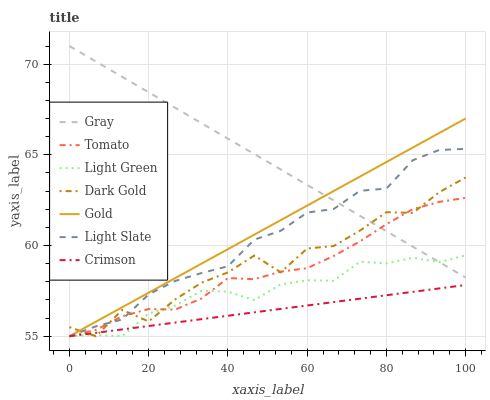Does Crimson have the minimum area under the curve?
Answer yes or no. Yes. Does Gray have the maximum area under the curve?
Answer yes or no. Yes. Does Gold have the minimum area under the curve?
Answer yes or no. No. Does Gold have the maximum area under the curve?
Answer yes or no. No. Is Crimson the smoothest?
Answer yes or no. Yes. Is Dark Gold the roughest?
Answer yes or no. Yes. Is Gray the smoothest?
Answer yes or no. No. Is Gray the roughest?
Answer yes or no. No. Does Gray have the lowest value?
Answer yes or no. No. Does Gray have the highest value?
Answer yes or no. Yes. Does Gold have the highest value?
Answer yes or no. No. Is Crimson less than Gray?
Answer yes or no. Yes. Is Gray greater than Crimson?
Answer yes or no. Yes. Does Gold intersect Tomato?
Answer yes or no. Yes. Is Gold less than Tomato?
Answer yes or no. No. Is Gold greater than Tomato?
Answer yes or no. No. Does Crimson intersect Gray?
Answer yes or no. No. 